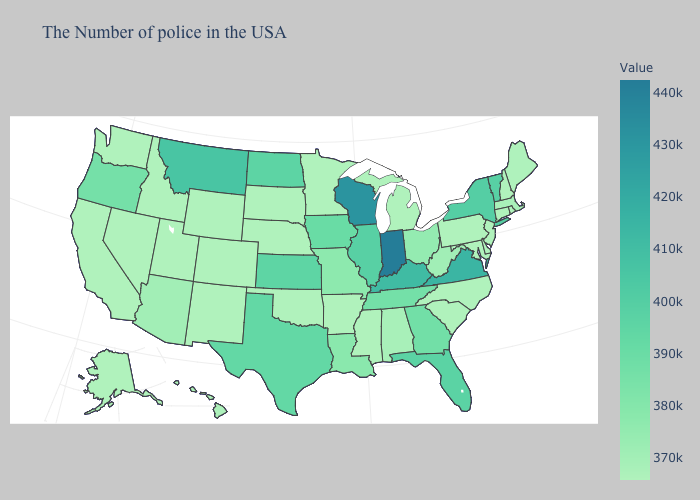Is the legend a continuous bar?
Be succinct. Yes. Does Kansas have a lower value than Indiana?
Short answer required. Yes. Is the legend a continuous bar?
Be succinct. Yes. Does Illinois have a higher value than Kentucky?
Short answer required. No. Does Indiana have the highest value in the USA?
Concise answer only. Yes. Does West Virginia have the highest value in the USA?
Concise answer only. No. 